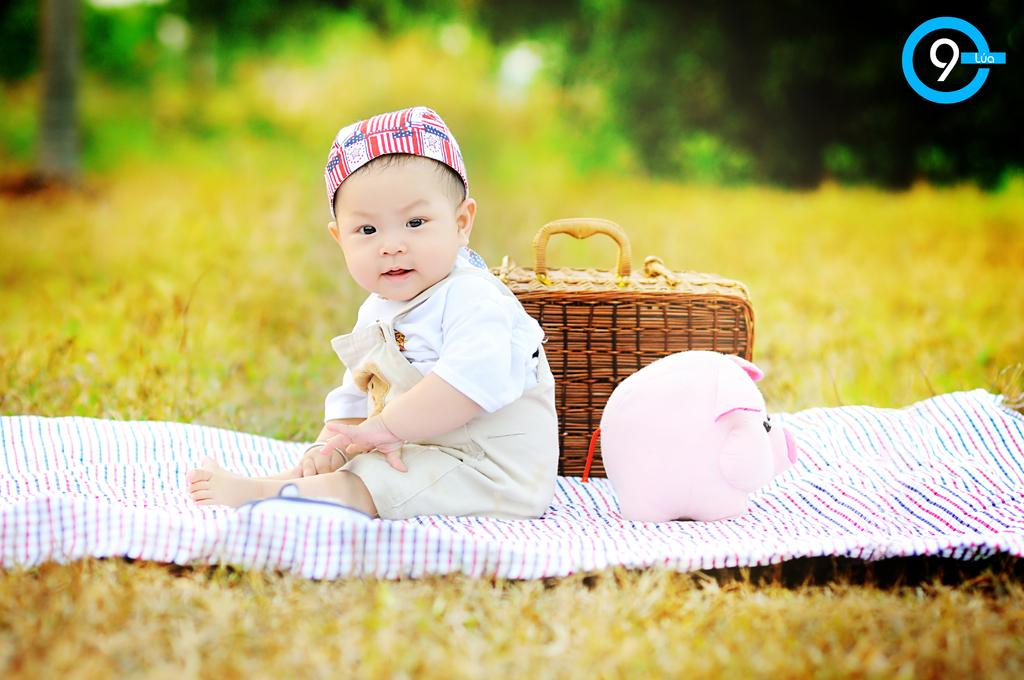What is the kid doing in the image? The kid is sitting on a carpet in the image. What can be seen behind the kid? There is a soft toy and a basket behind the kid. What is visible in the background of the image? Trees are visible in the background of the image. How would you describe the background of the image? The background is blurry. What type of attraction can be seen in the background of the image? There is no attraction visible in the background of the image; it features trees. Can you tell me how many calculators are present in the image? There are no calculators present in the image. 